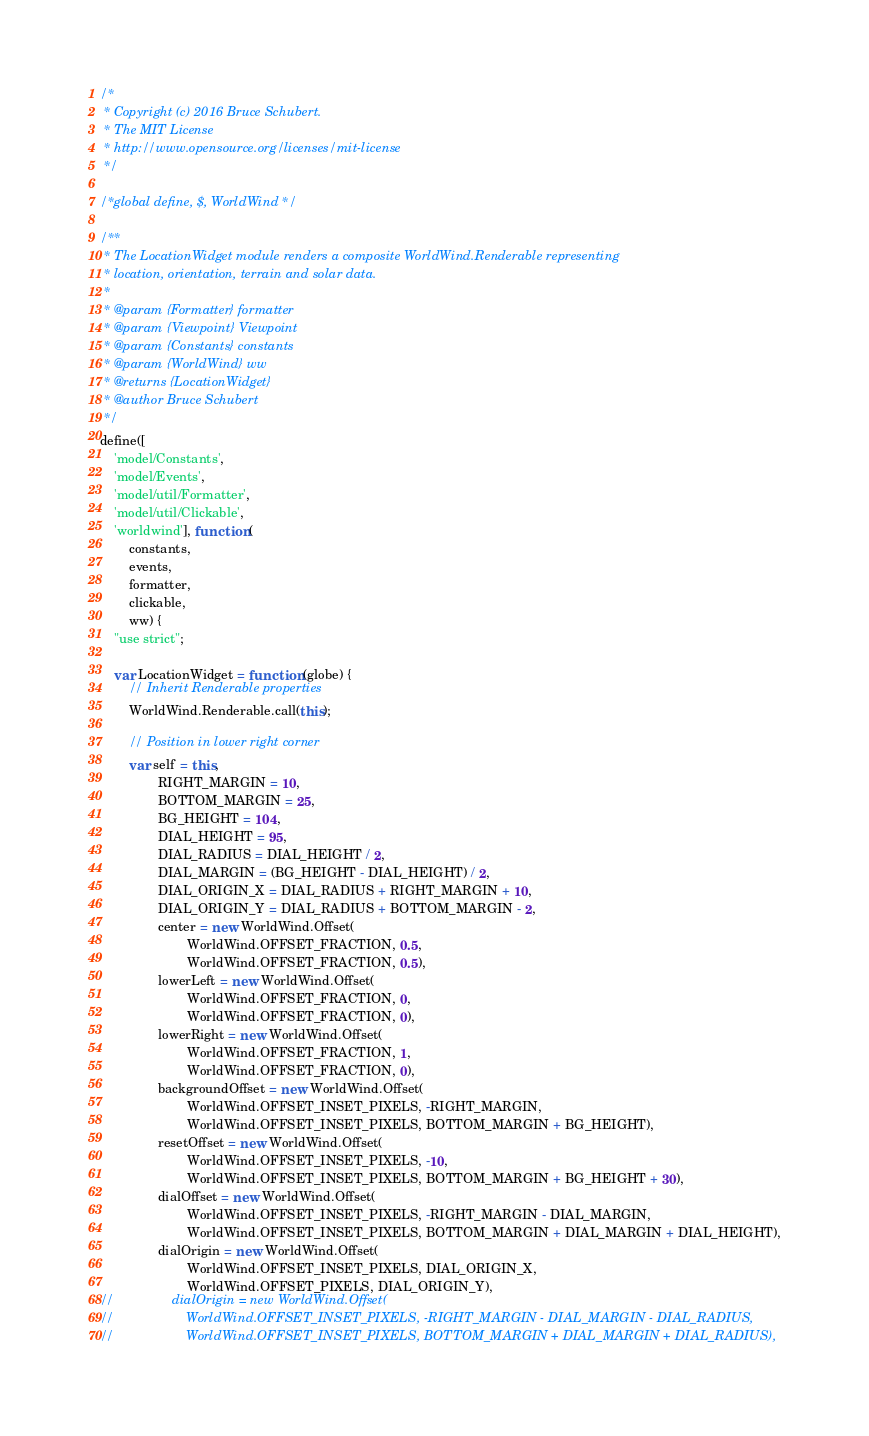<code> <loc_0><loc_0><loc_500><loc_500><_JavaScript_>/* 
 * Copyright (c) 2016 Bruce Schubert.
 * The MIT License
 * http://www.opensource.org/licenses/mit-license
 */

/*global define, $, WorldWind */

/**
 * The LocationWidget module renders a composite WorldWind.Renderable representing 
 * location, orientation, terrain and solar data.
 * 
 * @param {Formatter} formatter
 * @param {Viewpoint} Viewpoint
 * @param {Constants} constants
 * @param {WorldWind} ww
 * @returns {LocationWidget}
 * @author Bruce Schubert
 */
define([
    'model/Constants',
    'model/Events',
    'model/util/Formatter',
    'model/util/Clickable',
    'worldwind'], function (
        constants,
        events,
        formatter,
        clickable,
        ww) {
    "use strict";

    var LocationWidget = function (globe) {
        // Inherit Renderable properties
        WorldWind.Renderable.call(this);

        // Position in lower right corner
        var self = this,
                RIGHT_MARGIN = 10,
                BOTTOM_MARGIN = 25,
                BG_HEIGHT = 104,
                DIAL_HEIGHT = 95,
                DIAL_RADIUS = DIAL_HEIGHT / 2,
                DIAL_MARGIN = (BG_HEIGHT - DIAL_HEIGHT) / 2,
                DIAL_ORIGIN_X = DIAL_RADIUS + RIGHT_MARGIN + 10,
                DIAL_ORIGIN_Y = DIAL_RADIUS + BOTTOM_MARGIN - 2,
                center = new WorldWind.Offset(
                        WorldWind.OFFSET_FRACTION, 0.5,
                        WorldWind.OFFSET_FRACTION, 0.5),
                lowerLeft = new WorldWind.Offset(
                        WorldWind.OFFSET_FRACTION, 0,
                        WorldWind.OFFSET_FRACTION, 0),
                lowerRight = new WorldWind.Offset(
                        WorldWind.OFFSET_FRACTION, 1,
                        WorldWind.OFFSET_FRACTION, 0),
                backgroundOffset = new WorldWind.Offset(
                        WorldWind.OFFSET_INSET_PIXELS, -RIGHT_MARGIN,
                        WorldWind.OFFSET_INSET_PIXELS, BOTTOM_MARGIN + BG_HEIGHT),
                resetOffset = new WorldWind.Offset(
                        WorldWind.OFFSET_INSET_PIXELS, -10,
                        WorldWind.OFFSET_INSET_PIXELS, BOTTOM_MARGIN + BG_HEIGHT + 30),
                dialOffset = new WorldWind.Offset(
                        WorldWind.OFFSET_INSET_PIXELS, -RIGHT_MARGIN - DIAL_MARGIN,
                        WorldWind.OFFSET_INSET_PIXELS, BOTTOM_MARGIN + DIAL_MARGIN + DIAL_HEIGHT),
                dialOrigin = new WorldWind.Offset(
                        WorldWind.OFFSET_INSET_PIXELS, DIAL_ORIGIN_X,
                        WorldWind.OFFSET_PIXELS, DIAL_ORIGIN_Y),
//                dialOrigin = new WorldWind.Offset(
//                    WorldWind.OFFSET_INSET_PIXELS, -RIGHT_MARGIN - DIAL_MARGIN - DIAL_RADIUS,
//                    WorldWind.OFFSET_INSET_PIXELS, BOTTOM_MARGIN + DIAL_MARGIN + DIAL_RADIUS),</code> 